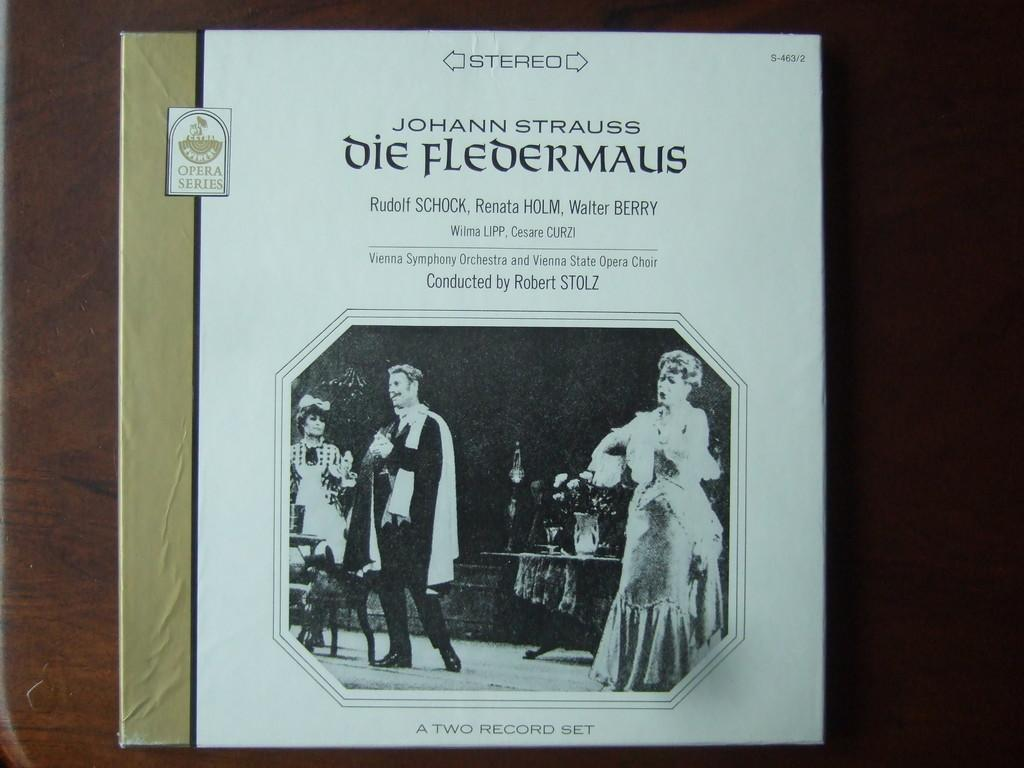<image>
Provide a brief description of the given image. A two record set of an opera series sitting on a table. 